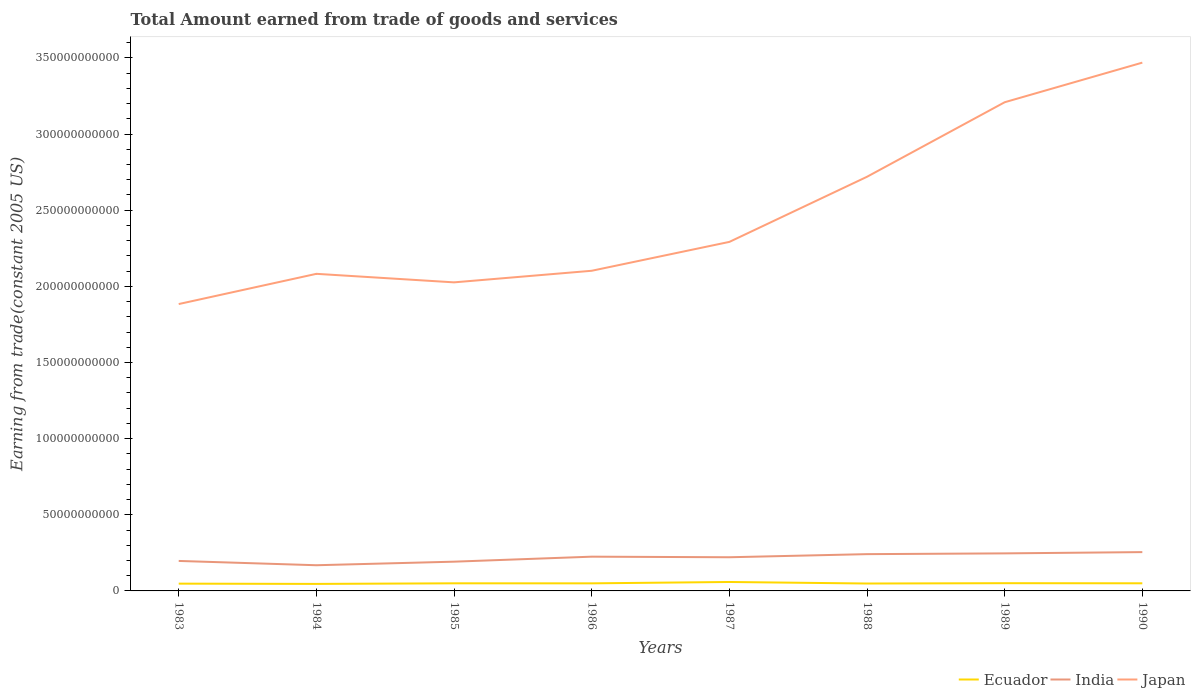How many different coloured lines are there?
Your answer should be very brief. 3. Is the number of lines equal to the number of legend labels?
Give a very brief answer. Yes. Across all years, what is the maximum total amount earned by trading goods and services in Japan?
Give a very brief answer. 1.88e+11. What is the total total amount earned by trading goods and services in Japan in the graph?
Provide a succinct answer. 5.60e+09. What is the difference between the highest and the second highest total amount earned by trading goods and services in Ecuador?
Provide a short and direct response. 1.26e+09. Is the total amount earned by trading goods and services in India strictly greater than the total amount earned by trading goods and services in Ecuador over the years?
Provide a short and direct response. No. How many years are there in the graph?
Offer a very short reply. 8. What is the difference between two consecutive major ticks on the Y-axis?
Provide a succinct answer. 5.00e+1. Where does the legend appear in the graph?
Provide a succinct answer. Bottom right. What is the title of the graph?
Offer a terse response. Total Amount earned from trade of goods and services. Does "Ireland" appear as one of the legend labels in the graph?
Provide a short and direct response. No. What is the label or title of the X-axis?
Provide a succinct answer. Years. What is the label or title of the Y-axis?
Your response must be concise. Earning from trade(constant 2005 US). What is the Earning from trade(constant 2005 US) in Ecuador in 1983?
Offer a terse response. 4.78e+09. What is the Earning from trade(constant 2005 US) of India in 1983?
Your answer should be compact. 1.97e+1. What is the Earning from trade(constant 2005 US) in Japan in 1983?
Provide a succinct answer. 1.88e+11. What is the Earning from trade(constant 2005 US) of Ecuador in 1984?
Your answer should be compact. 4.61e+09. What is the Earning from trade(constant 2005 US) in India in 1984?
Your answer should be compact. 1.69e+1. What is the Earning from trade(constant 2005 US) in Japan in 1984?
Give a very brief answer. 2.08e+11. What is the Earning from trade(constant 2005 US) of Ecuador in 1985?
Your answer should be very brief. 5.00e+09. What is the Earning from trade(constant 2005 US) in India in 1985?
Offer a terse response. 1.92e+1. What is the Earning from trade(constant 2005 US) of Japan in 1985?
Provide a short and direct response. 2.03e+11. What is the Earning from trade(constant 2005 US) in Ecuador in 1986?
Provide a short and direct response. 4.98e+09. What is the Earning from trade(constant 2005 US) of India in 1986?
Keep it short and to the point. 2.25e+1. What is the Earning from trade(constant 2005 US) of Japan in 1986?
Offer a terse response. 2.10e+11. What is the Earning from trade(constant 2005 US) in Ecuador in 1987?
Keep it short and to the point. 5.87e+09. What is the Earning from trade(constant 2005 US) of India in 1987?
Your answer should be very brief. 2.21e+1. What is the Earning from trade(constant 2005 US) of Japan in 1987?
Offer a terse response. 2.29e+11. What is the Earning from trade(constant 2005 US) of Ecuador in 1988?
Keep it short and to the point. 4.86e+09. What is the Earning from trade(constant 2005 US) of India in 1988?
Ensure brevity in your answer.  2.41e+1. What is the Earning from trade(constant 2005 US) in Japan in 1988?
Your response must be concise. 2.72e+11. What is the Earning from trade(constant 2005 US) in Ecuador in 1989?
Provide a succinct answer. 5.08e+09. What is the Earning from trade(constant 2005 US) in India in 1989?
Your answer should be very brief. 2.47e+1. What is the Earning from trade(constant 2005 US) of Japan in 1989?
Offer a terse response. 3.21e+11. What is the Earning from trade(constant 2005 US) in Ecuador in 1990?
Provide a short and direct response. 5.00e+09. What is the Earning from trade(constant 2005 US) of India in 1990?
Provide a short and direct response. 2.55e+1. What is the Earning from trade(constant 2005 US) in Japan in 1990?
Offer a terse response. 3.47e+11. Across all years, what is the maximum Earning from trade(constant 2005 US) of Ecuador?
Provide a short and direct response. 5.87e+09. Across all years, what is the maximum Earning from trade(constant 2005 US) of India?
Give a very brief answer. 2.55e+1. Across all years, what is the maximum Earning from trade(constant 2005 US) of Japan?
Provide a short and direct response. 3.47e+11. Across all years, what is the minimum Earning from trade(constant 2005 US) of Ecuador?
Offer a terse response. 4.61e+09. Across all years, what is the minimum Earning from trade(constant 2005 US) in India?
Your answer should be compact. 1.69e+1. Across all years, what is the minimum Earning from trade(constant 2005 US) of Japan?
Offer a terse response. 1.88e+11. What is the total Earning from trade(constant 2005 US) of Ecuador in the graph?
Keep it short and to the point. 4.02e+1. What is the total Earning from trade(constant 2005 US) of India in the graph?
Keep it short and to the point. 1.75e+11. What is the total Earning from trade(constant 2005 US) in Japan in the graph?
Ensure brevity in your answer.  1.98e+12. What is the difference between the Earning from trade(constant 2005 US) of Ecuador in 1983 and that in 1984?
Give a very brief answer. 1.72e+08. What is the difference between the Earning from trade(constant 2005 US) of India in 1983 and that in 1984?
Offer a terse response. 2.82e+09. What is the difference between the Earning from trade(constant 2005 US) of Japan in 1983 and that in 1984?
Your answer should be compact. -1.98e+1. What is the difference between the Earning from trade(constant 2005 US) of Ecuador in 1983 and that in 1985?
Offer a very short reply. -2.21e+08. What is the difference between the Earning from trade(constant 2005 US) of India in 1983 and that in 1985?
Give a very brief answer. 4.82e+08. What is the difference between the Earning from trade(constant 2005 US) of Japan in 1983 and that in 1985?
Your answer should be very brief. -1.42e+1. What is the difference between the Earning from trade(constant 2005 US) in Ecuador in 1983 and that in 1986?
Provide a succinct answer. -1.95e+08. What is the difference between the Earning from trade(constant 2005 US) in India in 1983 and that in 1986?
Provide a succinct answer. -2.80e+09. What is the difference between the Earning from trade(constant 2005 US) of Japan in 1983 and that in 1986?
Keep it short and to the point. -2.19e+1. What is the difference between the Earning from trade(constant 2005 US) in Ecuador in 1983 and that in 1987?
Provide a succinct answer. -1.09e+09. What is the difference between the Earning from trade(constant 2005 US) of India in 1983 and that in 1987?
Give a very brief answer. -2.42e+09. What is the difference between the Earning from trade(constant 2005 US) in Japan in 1983 and that in 1987?
Your answer should be compact. -4.08e+1. What is the difference between the Earning from trade(constant 2005 US) of Ecuador in 1983 and that in 1988?
Offer a terse response. -8.02e+07. What is the difference between the Earning from trade(constant 2005 US) of India in 1983 and that in 1988?
Provide a succinct answer. -4.46e+09. What is the difference between the Earning from trade(constant 2005 US) of Japan in 1983 and that in 1988?
Offer a terse response. -8.36e+1. What is the difference between the Earning from trade(constant 2005 US) in Ecuador in 1983 and that in 1989?
Your response must be concise. -3.02e+08. What is the difference between the Earning from trade(constant 2005 US) in India in 1983 and that in 1989?
Provide a short and direct response. -4.96e+09. What is the difference between the Earning from trade(constant 2005 US) in Japan in 1983 and that in 1989?
Provide a short and direct response. -1.33e+11. What is the difference between the Earning from trade(constant 2005 US) of Ecuador in 1983 and that in 1990?
Your response must be concise. -2.23e+08. What is the difference between the Earning from trade(constant 2005 US) in India in 1983 and that in 1990?
Ensure brevity in your answer.  -5.79e+09. What is the difference between the Earning from trade(constant 2005 US) of Japan in 1983 and that in 1990?
Offer a terse response. -1.59e+11. What is the difference between the Earning from trade(constant 2005 US) in Ecuador in 1984 and that in 1985?
Your response must be concise. -3.92e+08. What is the difference between the Earning from trade(constant 2005 US) of India in 1984 and that in 1985?
Your answer should be very brief. -2.34e+09. What is the difference between the Earning from trade(constant 2005 US) of Japan in 1984 and that in 1985?
Your response must be concise. 5.60e+09. What is the difference between the Earning from trade(constant 2005 US) of Ecuador in 1984 and that in 1986?
Your answer should be very brief. -3.67e+08. What is the difference between the Earning from trade(constant 2005 US) of India in 1984 and that in 1986?
Keep it short and to the point. -5.62e+09. What is the difference between the Earning from trade(constant 2005 US) of Japan in 1984 and that in 1986?
Offer a very short reply. -2.01e+09. What is the difference between the Earning from trade(constant 2005 US) in Ecuador in 1984 and that in 1987?
Your answer should be very brief. -1.26e+09. What is the difference between the Earning from trade(constant 2005 US) in India in 1984 and that in 1987?
Provide a short and direct response. -5.25e+09. What is the difference between the Earning from trade(constant 2005 US) in Japan in 1984 and that in 1987?
Make the answer very short. -2.10e+1. What is the difference between the Earning from trade(constant 2005 US) of Ecuador in 1984 and that in 1988?
Provide a succinct answer. -2.52e+08. What is the difference between the Earning from trade(constant 2005 US) in India in 1984 and that in 1988?
Ensure brevity in your answer.  -7.28e+09. What is the difference between the Earning from trade(constant 2005 US) of Japan in 1984 and that in 1988?
Offer a very short reply. -6.37e+1. What is the difference between the Earning from trade(constant 2005 US) in Ecuador in 1984 and that in 1989?
Provide a succinct answer. -4.74e+08. What is the difference between the Earning from trade(constant 2005 US) of India in 1984 and that in 1989?
Ensure brevity in your answer.  -7.78e+09. What is the difference between the Earning from trade(constant 2005 US) of Japan in 1984 and that in 1989?
Make the answer very short. -1.13e+11. What is the difference between the Earning from trade(constant 2005 US) in Ecuador in 1984 and that in 1990?
Make the answer very short. -3.95e+08. What is the difference between the Earning from trade(constant 2005 US) of India in 1984 and that in 1990?
Ensure brevity in your answer.  -8.61e+09. What is the difference between the Earning from trade(constant 2005 US) in Japan in 1984 and that in 1990?
Offer a very short reply. -1.39e+11. What is the difference between the Earning from trade(constant 2005 US) of Ecuador in 1985 and that in 1986?
Ensure brevity in your answer.  2.52e+07. What is the difference between the Earning from trade(constant 2005 US) in India in 1985 and that in 1986?
Your response must be concise. -3.28e+09. What is the difference between the Earning from trade(constant 2005 US) of Japan in 1985 and that in 1986?
Provide a succinct answer. -7.61e+09. What is the difference between the Earning from trade(constant 2005 US) in Ecuador in 1985 and that in 1987?
Provide a succinct answer. -8.69e+08. What is the difference between the Earning from trade(constant 2005 US) of India in 1985 and that in 1987?
Provide a succinct answer. -2.91e+09. What is the difference between the Earning from trade(constant 2005 US) in Japan in 1985 and that in 1987?
Your answer should be very brief. -2.66e+1. What is the difference between the Earning from trade(constant 2005 US) in Ecuador in 1985 and that in 1988?
Keep it short and to the point. 1.40e+08. What is the difference between the Earning from trade(constant 2005 US) of India in 1985 and that in 1988?
Make the answer very short. -4.94e+09. What is the difference between the Earning from trade(constant 2005 US) in Japan in 1985 and that in 1988?
Ensure brevity in your answer.  -6.93e+1. What is the difference between the Earning from trade(constant 2005 US) of Ecuador in 1985 and that in 1989?
Offer a terse response. -8.14e+07. What is the difference between the Earning from trade(constant 2005 US) of India in 1985 and that in 1989?
Provide a short and direct response. -5.44e+09. What is the difference between the Earning from trade(constant 2005 US) in Japan in 1985 and that in 1989?
Ensure brevity in your answer.  -1.18e+11. What is the difference between the Earning from trade(constant 2005 US) of Ecuador in 1985 and that in 1990?
Keep it short and to the point. -2.39e+06. What is the difference between the Earning from trade(constant 2005 US) in India in 1985 and that in 1990?
Give a very brief answer. -6.27e+09. What is the difference between the Earning from trade(constant 2005 US) of Japan in 1985 and that in 1990?
Give a very brief answer. -1.44e+11. What is the difference between the Earning from trade(constant 2005 US) in Ecuador in 1986 and that in 1987?
Give a very brief answer. -8.94e+08. What is the difference between the Earning from trade(constant 2005 US) in India in 1986 and that in 1987?
Make the answer very short. 3.75e+08. What is the difference between the Earning from trade(constant 2005 US) in Japan in 1986 and that in 1987?
Make the answer very short. -1.90e+1. What is the difference between the Earning from trade(constant 2005 US) of Ecuador in 1986 and that in 1988?
Offer a terse response. 1.15e+08. What is the difference between the Earning from trade(constant 2005 US) in India in 1986 and that in 1988?
Make the answer very short. -1.66e+09. What is the difference between the Earning from trade(constant 2005 US) in Japan in 1986 and that in 1988?
Your response must be concise. -6.17e+1. What is the difference between the Earning from trade(constant 2005 US) in Ecuador in 1986 and that in 1989?
Give a very brief answer. -1.07e+08. What is the difference between the Earning from trade(constant 2005 US) of India in 1986 and that in 1989?
Your answer should be compact. -2.16e+09. What is the difference between the Earning from trade(constant 2005 US) in Japan in 1986 and that in 1989?
Ensure brevity in your answer.  -1.11e+11. What is the difference between the Earning from trade(constant 2005 US) of Ecuador in 1986 and that in 1990?
Your answer should be compact. -2.76e+07. What is the difference between the Earning from trade(constant 2005 US) in India in 1986 and that in 1990?
Ensure brevity in your answer.  -2.99e+09. What is the difference between the Earning from trade(constant 2005 US) of Japan in 1986 and that in 1990?
Your answer should be compact. -1.37e+11. What is the difference between the Earning from trade(constant 2005 US) in Ecuador in 1987 and that in 1988?
Provide a succinct answer. 1.01e+09. What is the difference between the Earning from trade(constant 2005 US) in India in 1987 and that in 1988?
Provide a short and direct response. -2.03e+09. What is the difference between the Earning from trade(constant 2005 US) in Japan in 1987 and that in 1988?
Offer a terse response. -4.28e+1. What is the difference between the Earning from trade(constant 2005 US) in Ecuador in 1987 and that in 1989?
Make the answer very short. 7.87e+08. What is the difference between the Earning from trade(constant 2005 US) in India in 1987 and that in 1989?
Your answer should be compact. -2.54e+09. What is the difference between the Earning from trade(constant 2005 US) in Japan in 1987 and that in 1989?
Offer a very short reply. -9.17e+1. What is the difference between the Earning from trade(constant 2005 US) in Ecuador in 1987 and that in 1990?
Provide a succinct answer. 8.66e+08. What is the difference between the Earning from trade(constant 2005 US) of India in 1987 and that in 1990?
Your response must be concise. -3.37e+09. What is the difference between the Earning from trade(constant 2005 US) of Japan in 1987 and that in 1990?
Your answer should be compact. -1.18e+11. What is the difference between the Earning from trade(constant 2005 US) in Ecuador in 1988 and that in 1989?
Offer a terse response. -2.22e+08. What is the difference between the Earning from trade(constant 2005 US) of India in 1988 and that in 1989?
Provide a short and direct response. -5.03e+08. What is the difference between the Earning from trade(constant 2005 US) in Japan in 1988 and that in 1989?
Make the answer very short. -4.89e+1. What is the difference between the Earning from trade(constant 2005 US) in Ecuador in 1988 and that in 1990?
Make the answer very short. -1.43e+08. What is the difference between the Earning from trade(constant 2005 US) in India in 1988 and that in 1990?
Provide a short and direct response. -1.33e+09. What is the difference between the Earning from trade(constant 2005 US) in Japan in 1988 and that in 1990?
Make the answer very short. -7.49e+1. What is the difference between the Earning from trade(constant 2005 US) of Ecuador in 1989 and that in 1990?
Ensure brevity in your answer.  7.90e+07. What is the difference between the Earning from trade(constant 2005 US) of India in 1989 and that in 1990?
Your answer should be compact. -8.30e+08. What is the difference between the Earning from trade(constant 2005 US) in Japan in 1989 and that in 1990?
Give a very brief answer. -2.60e+1. What is the difference between the Earning from trade(constant 2005 US) of Ecuador in 1983 and the Earning from trade(constant 2005 US) of India in 1984?
Offer a terse response. -1.21e+1. What is the difference between the Earning from trade(constant 2005 US) of Ecuador in 1983 and the Earning from trade(constant 2005 US) of Japan in 1984?
Your answer should be compact. -2.03e+11. What is the difference between the Earning from trade(constant 2005 US) in India in 1983 and the Earning from trade(constant 2005 US) in Japan in 1984?
Make the answer very short. -1.89e+11. What is the difference between the Earning from trade(constant 2005 US) of Ecuador in 1983 and the Earning from trade(constant 2005 US) of India in 1985?
Ensure brevity in your answer.  -1.44e+1. What is the difference between the Earning from trade(constant 2005 US) in Ecuador in 1983 and the Earning from trade(constant 2005 US) in Japan in 1985?
Make the answer very short. -1.98e+11. What is the difference between the Earning from trade(constant 2005 US) in India in 1983 and the Earning from trade(constant 2005 US) in Japan in 1985?
Keep it short and to the point. -1.83e+11. What is the difference between the Earning from trade(constant 2005 US) of Ecuador in 1983 and the Earning from trade(constant 2005 US) of India in 1986?
Your response must be concise. -1.77e+1. What is the difference between the Earning from trade(constant 2005 US) in Ecuador in 1983 and the Earning from trade(constant 2005 US) in Japan in 1986?
Provide a succinct answer. -2.05e+11. What is the difference between the Earning from trade(constant 2005 US) in India in 1983 and the Earning from trade(constant 2005 US) in Japan in 1986?
Your response must be concise. -1.91e+11. What is the difference between the Earning from trade(constant 2005 US) in Ecuador in 1983 and the Earning from trade(constant 2005 US) in India in 1987?
Make the answer very short. -1.73e+1. What is the difference between the Earning from trade(constant 2005 US) in Ecuador in 1983 and the Earning from trade(constant 2005 US) in Japan in 1987?
Give a very brief answer. -2.24e+11. What is the difference between the Earning from trade(constant 2005 US) in India in 1983 and the Earning from trade(constant 2005 US) in Japan in 1987?
Provide a short and direct response. -2.09e+11. What is the difference between the Earning from trade(constant 2005 US) in Ecuador in 1983 and the Earning from trade(constant 2005 US) in India in 1988?
Make the answer very short. -1.94e+1. What is the difference between the Earning from trade(constant 2005 US) of Ecuador in 1983 and the Earning from trade(constant 2005 US) of Japan in 1988?
Offer a terse response. -2.67e+11. What is the difference between the Earning from trade(constant 2005 US) of India in 1983 and the Earning from trade(constant 2005 US) of Japan in 1988?
Ensure brevity in your answer.  -2.52e+11. What is the difference between the Earning from trade(constant 2005 US) in Ecuador in 1983 and the Earning from trade(constant 2005 US) in India in 1989?
Your response must be concise. -1.99e+1. What is the difference between the Earning from trade(constant 2005 US) of Ecuador in 1983 and the Earning from trade(constant 2005 US) of Japan in 1989?
Offer a very short reply. -3.16e+11. What is the difference between the Earning from trade(constant 2005 US) of India in 1983 and the Earning from trade(constant 2005 US) of Japan in 1989?
Your response must be concise. -3.01e+11. What is the difference between the Earning from trade(constant 2005 US) in Ecuador in 1983 and the Earning from trade(constant 2005 US) in India in 1990?
Your answer should be very brief. -2.07e+1. What is the difference between the Earning from trade(constant 2005 US) in Ecuador in 1983 and the Earning from trade(constant 2005 US) in Japan in 1990?
Offer a very short reply. -3.42e+11. What is the difference between the Earning from trade(constant 2005 US) of India in 1983 and the Earning from trade(constant 2005 US) of Japan in 1990?
Offer a terse response. -3.27e+11. What is the difference between the Earning from trade(constant 2005 US) of Ecuador in 1984 and the Earning from trade(constant 2005 US) of India in 1985?
Your answer should be compact. -1.46e+1. What is the difference between the Earning from trade(constant 2005 US) of Ecuador in 1984 and the Earning from trade(constant 2005 US) of Japan in 1985?
Your answer should be very brief. -1.98e+11. What is the difference between the Earning from trade(constant 2005 US) of India in 1984 and the Earning from trade(constant 2005 US) of Japan in 1985?
Your answer should be very brief. -1.86e+11. What is the difference between the Earning from trade(constant 2005 US) in Ecuador in 1984 and the Earning from trade(constant 2005 US) in India in 1986?
Provide a short and direct response. -1.79e+1. What is the difference between the Earning from trade(constant 2005 US) in Ecuador in 1984 and the Earning from trade(constant 2005 US) in Japan in 1986?
Offer a terse response. -2.06e+11. What is the difference between the Earning from trade(constant 2005 US) of India in 1984 and the Earning from trade(constant 2005 US) of Japan in 1986?
Ensure brevity in your answer.  -1.93e+11. What is the difference between the Earning from trade(constant 2005 US) of Ecuador in 1984 and the Earning from trade(constant 2005 US) of India in 1987?
Offer a very short reply. -1.75e+1. What is the difference between the Earning from trade(constant 2005 US) of Ecuador in 1984 and the Earning from trade(constant 2005 US) of Japan in 1987?
Ensure brevity in your answer.  -2.25e+11. What is the difference between the Earning from trade(constant 2005 US) in India in 1984 and the Earning from trade(constant 2005 US) in Japan in 1987?
Provide a succinct answer. -2.12e+11. What is the difference between the Earning from trade(constant 2005 US) of Ecuador in 1984 and the Earning from trade(constant 2005 US) of India in 1988?
Your answer should be compact. -1.95e+1. What is the difference between the Earning from trade(constant 2005 US) of Ecuador in 1984 and the Earning from trade(constant 2005 US) of Japan in 1988?
Keep it short and to the point. -2.67e+11. What is the difference between the Earning from trade(constant 2005 US) in India in 1984 and the Earning from trade(constant 2005 US) in Japan in 1988?
Offer a terse response. -2.55e+11. What is the difference between the Earning from trade(constant 2005 US) of Ecuador in 1984 and the Earning from trade(constant 2005 US) of India in 1989?
Make the answer very short. -2.00e+1. What is the difference between the Earning from trade(constant 2005 US) in Ecuador in 1984 and the Earning from trade(constant 2005 US) in Japan in 1989?
Your response must be concise. -3.16e+11. What is the difference between the Earning from trade(constant 2005 US) of India in 1984 and the Earning from trade(constant 2005 US) of Japan in 1989?
Your answer should be very brief. -3.04e+11. What is the difference between the Earning from trade(constant 2005 US) in Ecuador in 1984 and the Earning from trade(constant 2005 US) in India in 1990?
Your answer should be compact. -2.09e+1. What is the difference between the Earning from trade(constant 2005 US) of Ecuador in 1984 and the Earning from trade(constant 2005 US) of Japan in 1990?
Ensure brevity in your answer.  -3.42e+11. What is the difference between the Earning from trade(constant 2005 US) of India in 1984 and the Earning from trade(constant 2005 US) of Japan in 1990?
Give a very brief answer. -3.30e+11. What is the difference between the Earning from trade(constant 2005 US) in Ecuador in 1985 and the Earning from trade(constant 2005 US) in India in 1986?
Give a very brief answer. -1.75e+1. What is the difference between the Earning from trade(constant 2005 US) in Ecuador in 1985 and the Earning from trade(constant 2005 US) in Japan in 1986?
Your response must be concise. -2.05e+11. What is the difference between the Earning from trade(constant 2005 US) of India in 1985 and the Earning from trade(constant 2005 US) of Japan in 1986?
Keep it short and to the point. -1.91e+11. What is the difference between the Earning from trade(constant 2005 US) of Ecuador in 1985 and the Earning from trade(constant 2005 US) of India in 1987?
Offer a terse response. -1.71e+1. What is the difference between the Earning from trade(constant 2005 US) of Ecuador in 1985 and the Earning from trade(constant 2005 US) of Japan in 1987?
Provide a succinct answer. -2.24e+11. What is the difference between the Earning from trade(constant 2005 US) of India in 1985 and the Earning from trade(constant 2005 US) of Japan in 1987?
Keep it short and to the point. -2.10e+11. What is the difference between the Earning from trade(constant 2005 US) of Ecuador in 1985 and the Earning from trade(constant 2005 US) of India in 1988?
Offer a very short reply. -1.91e+1. What is the difference between the Earning from trade(constant 2005 US) in Ecuador in 1985 and the Earning from trade(constant 2005 US) in Japan in 1988?
Your response must be concise. -2.67e+11. What is the difference between the Earning from trade(constant 2005 US) of India in 1985 and the Earning from trade(constant 2005 US) of Japan in 1988?
Keep it short and to the point. -2.53e+11. What is the difference between the Earning from trade(constant 2005 US) in Ecuador in 1985 and the Earning from trade(constant 2005 US) in India in 1989?
Offer a very short reply. -1.96e+1. What is the difference between the Earning from trade(constant 2005 US) of Ecuador in 1985 and the Earning from trade(constant 2005 US) of Japan in 1989?
Give a very brief answer. -3.16e+11. What is the difference between the Earning from trade(constant 2005 US) in India in 1985 and the Earning from trade(constant 2005 US) in Japan in 1989?
Your answer should be compact. -3.02e+11. What is the difference between the Earning from trade(constant 2005 US) of Ecuador in 1985 and the Earning from trade(constant 2005 US) of India in 1990?
Your response must be concise. -2.05e+1. What is the difference between the Earning from trade(constant 2005 US) in Ecuador in 1985 and the Earning from trade(constant 2005 US) in Japan in 1990?
Your answer should be very brief. -3.42e+11. What is the difference between the Earning from trade(constant 2005 US) of India in 1985 and the Earning from trade(constant 2005 US) of Japan in 1990?
Your answer should be compact. -3.28e+11. What is the difference between the Earning from trade(constant 2005 US) of Ecuador in 1986 and the Earning from trade(constant 2005 US) of India in 1987?
Your answer should be compact. -1.71e+1. What is the difference between the Earning from trade(constant 2005 US) in Ecuador in 1986 and the Earning from trade(constant 2005 US) in Japan in 1987?
Give a very brief answer. -2.24e+11. What is the difference between the Earning from trade(constant 2005 US) of India in 1986 and the Earning from trade(constant 2005 US) of Japan in 1987?
Make the answer very short. -2.07e+11. What is the difference between the Earning from trade(constant 2005 US) of Ecuador in 1986 and the Earning from trade(constant 2005 US) of India in 1988?
Ensure brevity in your answer.  -1.92e+1. What is the difference between the Earning from trade(constant 2005 US) in Ecuador in 1986 and the Earning from trade(constant 2005 US) in Japan in 1988?
Give a very brief answer. -2.67e+11. What is the difference between the Earning from trade(constant 2005 US) of India in 1986 and the Earning from trade(constant 2005 US) of Japan in 1988?
Give a very brief answer. -2.49e+11. What is the difference between the Earning from trade(constant 2005 US) in Ecuador in 1986 and the Earning from trade(constant 2005 US) in India in 1989?
Make the answer very short. -1.97e+1. What is the difference between the Earning from trade(constant 2005 US) of Ecuador in 1986 and the Earning from trade(constant 2005 US) of Japan in 1989?
Offer a very short reply. -3.16e+11. What is the difference between the Earning from trade(constant 2005 US) in India in 1986 and the Earning from trade(constant 2005 US) in Japan in 1989?
Offer a terse response. -2.98e+11. What is the difference between the Earning from trade(constant 2005 US) of Ecuador in 1986 and the Earning from trade(constant 2005 US) of India in 1990?
Ensure brevity in your answer.  -2.05e+1. What is the difference between the Earning from trade(constant 2005 US) of Ecuador in 1986 and the Earning from trade(constant 2005 US) of Japan in 1990?
Provide a short and direct response. -3.42e+11. What is the difference between the Earning from trade(constant 2005 US) in India in 1986 and the Earning from trade(constant 2005 US) in Japan in 1990?
Offer a terse response. -3.24e+11. What is the difference between the Earning from trade(constant 2005 US) of Ecuador in 1987 and the Earning from trade(constant 2005 US) of India in 1988?
Give a very brief answer. -1.83e+1. What is the difference between the Earning from trade(constant 2005 US) in Ecuador in 1987 and the Earning from trade(constant 2005 US) in Japan in 1988?
Your answer should be compact. -2.66e+11. What is the difference between the Earning from trade(constant 2005 US) in India in 1987 and the Earning from trade(constant 2005 US) in Japan in 1988?
Your answer should be compact. -2.50e+11. What is the difference between the Earning from trade(constant 2005 US) of Ecuador in 1987 and the Earning from trade(constant 2005 US) of India in 1989?
Your answer should be very brief. -1.88e+1. What is the difference between the Earning from trade(constant 2005 US) of Ecuador in 1987 and the Earning from trade(constant 2005 US) of Japan in 1989?
Give a very brief answer. -3.15e+11. What is the difference between the Earning from trade(constant 2005 US) of India in 1987 and the Earning from trade(constant 2005 US) of Japan in 1989?
Provide a short and direct response. -2.99e+11. What is the difference between the Earning from trade(constant 2005 US) of Ecuador in 1987 and the Earning from trade(constant 2005 US) of India in 1990?
Keep it short and to the point. -1.96e+1. What is the difference between the Earning from trade(constant 2005 US) of Ecuador in 1987 and the Earning from trade(constant 2005 US) of Japan in 1990?
Your answer should be compact. -3.41e+11. What is the difference between the Earning from trade(constant 2005 US) of India in 1987 and the Earning from trade(constant 2005 US) of Japan in 1990?
Make the answer very short. -3.25e+11. What is the difference between the Earning from trade(constant 2005 US) of Ecuador in 1988 and the Earning from trade(constant 2005 US) of India in 1989?
Your response must be concise. -1.98e+1. What is the difference between the Earning from trade(constant 2005 US) of Ecuador in 1988 and the Earning from trade(constant 2005 US) of Japan in 1989?
Give a very brief answer. -3.16e+11. What is the difference between the Earning from trade(constant 2005 US) of India in 1988 and the Earning from trade(constant 2005 US) of Japan in 1989?
Provide a short and direct response. -2.97e+11. What is the difference between the Earning from trade(constant 2005 US) of Ecuador in 1988 and the Earning from trade(constant 2005 US) of India in 1990?
Ensure brevity in your answer.  -2.06e+1. What is the difference between the Earning from trade(constant 2005 US) in Ecuador in 1988 and the Earning from trade(constant 2005 US) in Japan in 1990?
Ensure brevity in your answer.  -3.42e+11. What is the difference between the Earning from trade(constant 2005 US) in India in 1988 and the Earning from trade(constant 2005 US) in Japan in 1990?
Give a very brief answer. -3.23e+11. What is the difference between the Earning from trade(constant 2005 US) in Ecuador in 1989 and the Earning from trade(constant 2005 US) in India in 1990?
Offer a very short reply. -2.04e+1. What is the difference between the Earning from trade(constant 2005 US) in Ecuador in 1989 and the Earning from trade(constant 2005 US) in Japan in 1990?
Keep it short and to the point. -3.42e+11. What is the difference between the Earning from trade(constant 2005 US) in India in 1989 and the Earning from trade(constant 2005 US) in Japan in 1990?
Make the answer very short. -3.22e+11. What is the average Earning from trade(constant 2005 US) of Ecuador per year?
Offer a terse response. 5.02e+09. What is the average Earning from trade(constant 2005 US) of India per year?
Give a very brief answer. 2.18e+1. What is the average Earning from trade(constant 2005 US) of Japan per year?
Your answer should be very brief. 2.47e+11. In the year 1983, what is the difference between the Earning from trade(constant 2005 US) of Ecuador and Earning from trade(constant 2005 US) of India?
Give a very brief answer. -1.49e+1. In the year 1983, what is the difference between the Earning from trade(constant 2005 US) in Ecuador and Earning from trade(constant 2005 US) in Japan?
Give a very brief answer. -1.84e+11. In the year 1983, what is the difference between the Earning from trade(constant 2005 US) in India and Earning from trade(constant 2005 US) in Japan?
Make the answer very short. -1.69e+11. In the year 1984, what is the difference between the Earning from trade(constant 2005 US) in Ecuador and Earning from trade(constant 2005 US) in India?
Provide a succinct answer. -1.23e+1. In the year 1984, what is the difference between the Earning from trade(constant 2005 US) of Ecuador and Earning from trade(constant 2005 US) of Japan?
Provide a succinct answer. -2.04e+11. In the year 1984, what is the difference between the Earning from trade(constant 2005 US) of India and Earning from trade(constant 2005 US) of Japan?
Your answer should be compact. -1.91e+11. In the year 1985, what is the difference between the Earning from trade(constant 2005 US) in Ecuador and Earning from trade(constant 2005 US) in India?
Provide a succinct answer. -1.42e+1. In the year 1985, what is the difference between the Earning from trade(constant 2005 US) of Ecuador and Earning from trade(constant 2005 US) of Japan?
Offer a terse response. -1.98e+11. In the year 1985, what is the difference between the Earning from trade(constant 2005 US) in India and Earning from trade(constant 2005 US) in Japan?
Make the answer very short. -1.83e+11. In the year 1986, what is the difference between the Earning from trade(constant 2005 US) in Ecuador and Earning from trade(constant 2005 US) in India?
Your response must be concise. -1.75e+1. In the year 1986, what is the difference between the Earning from trade(constant 2005 US) of Ecuador and Earning from trade(constant 2005 US) of Japan?
Your answer should be very brief. -2.05e+11. In the year 1986, what is the difference between the Earning from trade(constant 2005 US) in India and Earning from trade(constant 2005 US) in Japan?
Ensure brevity in your answer.  -1.88e+11. In the year 1987, what is the difference between the Earning from trade(constant 2005 US) in Ecuador and Earning from trade(constant 2005 US) in India?
Offer a terse response. -1.62e+1. In the year 1987, what is the difference between the Earning from trade(constant 2005 US) in Ecuador and Earning from trade(constant 2005 US) in Japan?
Provide a short and direct response. -2.23e+11. In the year 1987, what is the difference between the Earning from trade(constant 2005 US) in India and Earning from trade(constant 2005 US) in Japan?
Give a very brief answer. -2.07e+11. In the year 1988, what is the difference between the Earning from trade(constant 2005 US) in Ecuador and Earning from trade(constant 2005 US) in India?
Offer a terse response. -1.93e+1. In the year 1988, what is the difference between the Earning from trade(constant 2005 US) in Ecuador and Earning from trade(constant 2005 US) in Japan?
Offer a terse response. -2.67e+11. In the year 1988, what is the difference between the Earning from trade(constant 2005 US) of India and Earning from trade(constant 2005 US) of Japan?
Make the answer very short. -2.48e+11. In the year 1989, what is the difference between the Earning from trade(constant 2005 US) in Ecuador and Earning from trade(constant 2005 US) in India?
Ensure brevity in your answer.  -1.96e+1. In the year 1989, what is the difference between the Earning from trade(constant 2005 US) in Ecuador and Earning from trade(constant 2005 US) in Japan?
Your answer should be very brief. -3.16e+11. In the year 1989, what is the difference between the Earning from trade(constant 2005 US) of India and Earning from trade(constant 2005 US) of Japan?
Provide a succinct answer. -2.96e+11. In the year 1990, what is the difference between the Earning from trade(constant 2005 US) of Ecuador and Earning from trade(constant 2005 US) of India?
Make the answer very short. -2.05e+1. In the year 1990, what is the difference between the Earning from trade(constant 2005 US) of Ecuador and Earning from trade(constant 2005 US) of Japan?
Give a very brief answer. -3.42e+11. In the year 1990, what is the difference between the Earning from trade(constant 2005 US) of India and Earning from trade(constant 2005 US) of Japan?
Provide a succinct answer. -3.21e+11. What is the ratio of the Earning from trade(constant 2005 US) of Ecuador in 1983 to that in 1984?
Give a very brief answer. 1.04. What is the ratio of the Earning from trade(constant 2005 US) of India in 1983 to that in 1984?
Ensure brevity in your answer.  1.17. What is the ratio of the Earning from trade(constant 2005 US) in Japan in 1983 to that in 1984?
Your answer should be very brief. 0.9. What is the ratio of the Earning from trade(constant 2005 US) in Ecuador in 1983 to that in 1985?
Make the answer very short. 0.96. What is the ratio of the Earning from trade(constant 2005 US) of India in 1983 to that in 1985?
Ensure brevity in your answer.  1.03. What is the ratio of the Earning from trade(constant 2005 US) of Japan in 1983 to that in 1985?
Ensure brevity in your answer.  0.93. What is the ratio of the Earning from trade(constant 2005 US) of Ecuador in 1983 to that in 1986?
Provide a short and direct response. 0.96. What is the ratio of the Earning from trade(constant 2005 US) in India in 1983 to that in 1986?
Your answer should be very brief. 0.88. What is the ratio of the Earning from trade(constant 2005 US) of Japan in 1983 to that in 1986?
Keep it short and to the point. 0.9. What is the ratio of the Earning from trade(constant 2005 US) of Ecuador in 1983 to that in 1987?
Your answer should be compact. 0.81. What is the ratio of the Earning from trade(constant 2005 US) of India in 1983 to that in 1987?
Provide a short and direct response. 0.89. What is the ratio of the Earning from trade(constant 2005 US) of Japan in 1983 to that in 1987?
Give a very brief answer. 0.82. What is the ratio of the Earning from trade(constant 2005 US) of Ecuador in 1983 to that in 1988?
Provide a succinct answer. 0.98. What is the ratio of the Earning from trade(constant 2005 US) in India in 1983 to that in 1988?
Your answer should be compact. 0.82. What is the ratio of the Earning from trade(constant 2005 US) of Japan in 1983 to that in 1988?
Offer a terse response. 0.69. What is the ratio of the Earning from trade(constant 2005 US) in Ecuador in 1983 to that in 1989?
Your answer should be very brief. 0.94. What is the ratio of the Earning from trade(constant 2005 US) of India in 1983 to that in 1989?
Make the answer very short. 0.8. What is the ratio of the Earning from trade(constant 2005 US) in Japan in 1983 to that in 1989?
Your answer should be very brief. 0.59. What is the ratio of the Earning from trade(constant 2005 US) in Ecuador in 1983 to that in 1990?
Provide a short and direct response. 0.96. What is the ratio of the Earning from trade(constant 2005 US) in India in 1983 to that in 1990?
Give a very brief answer. 0.77. What is the ratio of the Earning from trade(constant 2005 US) in Japan in 1983 to that in 1990?
Offer a terse response. 0.54. What is the ratio of the Earning from trade(constant 2005 US) of Ecuador in 1984 to that in 1985?
Offer a very short reply. 0.92. What is the ratio of the Earning from trade(constant 2005 US) of India in 1984 to that in 1985?
Offer a very short reply. 0.88. What is the ratio of the Earning from trade(constant 2005 US) of Japan in 1984 to that in 1985?
Ensure brevity in your answer.  1.03. What is the ratio of the Earning from trade(constant 2005 US) of Ecuador in 1984 to that in 1986?
Your response must be concise. 0.93. What is the ratio of the Earning from trade(constant 2005 US) of India in 1984 to that in 1986?
Your answer should be compact. 0.75. What is the ratio of the Earning from trade(constant 2005 US) in Ecuador in 1984 to that in 1987?
Offer a terse response. 0.79. What is the ratio of the Earning from trade(constant 2005 US) in India in 1984 to that in 1987?
Provide a succinct answer. 0.76. What is the ratio of the Earning from trade(constant 2005 US) of Japan in 1984 to that in 1987?
Ensure brevity in your answer.  0.91. What is the ratio of the Earning from trade(constant 2005 US) of Ecuador in 1984 to that in 1988?
Your answer should be compact. 0.95. What is the ratio of the Earning from trade(constant 2005 US) in India in 1984 to that in 1988?
Your answer should be very brief. 0.7. What is the ratio of the Earning from trade(constant 2005 US) of Japan in 1984 to that in 1988?
Give a very brief answer. 0.77. What is the ratio of the Earning from trade(constant 2005 US) in Ecuador in 1984 to that in 1989?
Your answer should be very brief. 0.91. What is the ratio of the Earning from trade(constant 2005 US) of India in 1984 to that in 1989?
Your response must be concise. 0.68. What is the ratio of the Earning from trade(constant 2005 US) of Japan in 1984 to that in 1989?
Ensure brevity in your answer.  0.65. What is the ratio of the Earning from trade(constant 2005 US) of Ecuador in 1984 to that in 1990?
Offer a very short reply. 0.92. What is the ratio of the Earning from trade(constant 2005 US) of India in 1984 to that in 1990?
Your answer should be compact. 0.66. What is the ratio of the Earning from trade(constant 2005 US) of Japan in 1984 to that in 1990?
Give a very brief answer. 0.6. What is the ratio of the Earning from trade(constant 2005 US) of Ecuador in 1985 to that in 1986?
Offer a very short reply. 1.01. What is the ratio of the Earning from trade(constant 2005 US) of India in 1985 to that in 1986?
Provide a short and direct response. 0.85. What is the ratio of the Earning from trade(constant 2005 US) in Japan in 1985 to that in 1986?
Ensure brevity in your answer.  0.96. What is the ratio of the Earning from trade(constant 2005 US) in Ecuador in 1985 to that in 1987?
Your answer should be very brief. 0.85. What is the ratio of the Earning from trade(constant 2005 US) in India in 1985 to that in 1987?
Offer a very short reply. 0.87. What is the ratio of the Earning from trade(constant 2005 US) of Japan in 1985 to that in 1987?
Your response must be concise. 0.88. What is the ratio of the Earning from trade(constant 2005 US) of Ecuador in 1985 to that in 1988?
Offer a very short reply. 1.03. What is the ratio of the Earning from trade(constant 2005 US) of India in 1985 to that in 1988?
Offer a very short reply. 0.8. What is the ratio of the Earning from trade(constant 2005 US) in Japan in 1985 to that in 1988?
Offer a terse response. 0.74. What is the ratio of the Earning from trade(constant 2005 US) of India in 1985 to that in 1989?
Your answer should be compact. 0.78. What is the ratio of the Earning from trade(constant 2005 US) of Japan in 1985 to that in 1989?
Keep it short and to the point. 0.63. What is the ratio of the Earning from trade(constant 2005 US) of India in 1985 to that in 1990?
Make the answer very short. 0.75. What is the ratio of the Earning from trade(constant 2005 US) of Japan in 1985 to that in 1990?
Provide a short and direct response. 0.58. What is the ratio of the Earning from trade(constant 2005 US) in Ecuador in 1986 to that in 1987?
Provide a short and direct response. 0.85. What is the ratio of the Earning from trade(constant 2005 US) in Japan in 1986 to that in 1987?
Offer a terse response. 0.92. What is the ratio of the Earning from trade(constant 2005 US) of Ecuador in 1986 to that in 1988?
Your response must be concise. 1.02. What is the ratio of the Earning from trade(constant 2005 US) of India in 1986 to that in 1988?
Your answer should be very brief. 0.93. What is the ratio of the Earning from trade(constant 2005 US) in Japan in 1986 to that in 1988?
Give a very brief answer. 0.77. What is the ratio of the Earning from trade(constant 2005 US) in Ecuador in 1986 to that in 1989?
Offer a terse response. 0.98. What is the ratio of the Earning from trade(constant 2005 US) in India in 1986 to that in 1989?
Offer a terse response. 0.91. What is the ratio of the Earning from trade(constant 2005 US) in Japan in 1986 to that in 1989?
Provide a short and direct response. 0.66. What is the ratio of the Earning from trade(constant 2005 US) of India in 1986 to that in 1990?
Your answer should be very brief. 0.88. What is the ratio of the Earning from trade(constant 2005 US) in Japan in 1986 to that in 1990?
Provide a short and direct response. 0.61. What is the ratio of the Earning from trade(constant 2005 US) in Ecuador in 1987 to that in 1988?
Offer a very short reply. 1.21. What is the ratio of the Earning from trade(constant 2005 US) in India in 1987 to that in 1988?
Your answer should be very brief. 0.92. What is the ratio of the Earning from trade(constant 2005 US) of Japan in 1987 to that in 1988?
Provide a short and direct response. 0.84. What is the ratio of the Earning from trade(constant 2005 US) of Ecuador in 1987 to that in 1989?
Keep it short and to the point. 1.15. What is the ratio of the Earning from trade(constant 2005 US) in India in 1987 to that in 1989?
Your answer should be compact. 0.9. What is the ratio of the Earning from trade(constant 2005 US) in Japan in 1987 to that in 1989?
Your answer should be very brief. 0.71. What is the ratio of the Earning from trade(constant 2005 US) of Ecuador in 1987 to that in 1990?
Your response must be concise. 1.17. What is the ratio of the Earning from trade(constant 2005 US) of India in 1987 to that in 1990?
Offer a very short reply. 0.87. What is the ratio of the Earning from trade(constant 2005 US) of Japan in 1987 to that in 1990?
Offer a very short reply. 0.66. What is the ratio of the Earning from trade(constant 2005 US) of Ecuador in 1988 to that in 1989?
Provide a succinct answer. 0.96. What is the ratio of the Earning from trade(constant 2005 US) of India in 1988 to that in 1989?
Offer a terse response. 0.98. What is the ratio of the Earning from trade(constant 2005 US) of Japan in 1988 to that in 1989?
Ensure brevity in your answer.  0.85. What is the ratio of the Earning from trade(constant 2005 US) of Ecuador in 1988 to that in 1990?
Your answer should be compact. 0.97. What is the ratio of the Earning from trade(constant 2005 US) of India in 1988 to that in 1990?
Your response must be concise. 0.95. What is the ratio of the Earning from trade(constant 2005 US) of Japan in 1988 to that in 1990?
Your response must be concise. 0.78. What is the ratio of the Earning from trade(constant 2005 US) in Ecuador in 1989 to that in 1990?
Give a very brief answer. 1.02. What is the ratio of the Earning from trade(constant 2005 US) of India in 1989 to that in 1990?
Your response must be concise. 0.97. What is the ratio of the Earning from trade(constant 2005 US) of Japan in 1989 to that in 1990?
Provide a succinct answer. 0.93. What is the difference between the highest and the second highest Earning from trade(constant 2005 US) of Ecuador?
Your response must be concise. 7.87e+08. What is the difference between the highest and the second highest Earning from trade(constant 2005 US) in India?
Provide a short and direct response. 8.30e+08. What is the difference between the highest and the second highest Earning from trade(constant 2005 US) in Japan?
Your answer should be very brief. 2.60e+1. What is the difference between the highest and the lowest Earning from trade(constant 2005 US) in Ecuador?
Offer a terse response. 1.26e+09. What is the difference between the highest and the lowest Earning from trade(constant 2005 US) in India?
Provide a short and direct response. 8.61e+09. What is the difference between the highest and the lowest Earning from trade(constant 2005 US) of Japan?
Ensure brevity in your answer.  1.59e+11. 